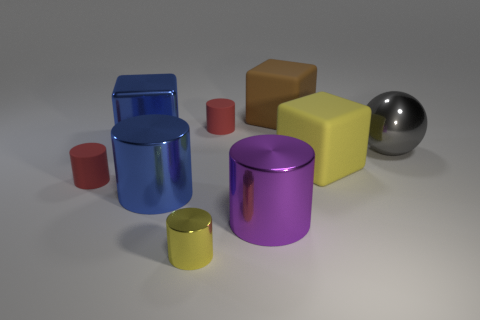Is the number of large yellow blocks in front of the yellow metal cylinder the same as the number of big blue metal things on the right side of the purple cylinder?
Provide a succinct answer. Yes. Are there any large purple spheres made of the same material as the large blue block?
Provide a short and direct response. No. Does the red cylinder that is in front of the yellow matte block have the same material as the large brown block?
Your response must be concise. Yes. What is the size of the object that is both behind the blue metal cylinder and in front of the yellow block?
Your answer should be compact. Small. What color is the shiny ball?
Your response must be concise. Gray. What number of tiny green shiny objects are there?
Your response must be concise. 0. What number of large cylinders have the same color as the large metallic block?
Your response must be concise. 1. Does the big blue object that is behind the blue metal cylinder have the same shape as the tiny red matte thing that is to the right of the yellow metal thing?
Make the answer very short. No. There is a large cube that is in front of the large gray shiny ball that is behind the tiny red matte cylinder that is to the left of the yellow cylinder; what is its color?
Your response must be concise. Yellow. The tiny matte object that is to the right of the big blue cylinder is what color?
Make the answer very short. Red. 